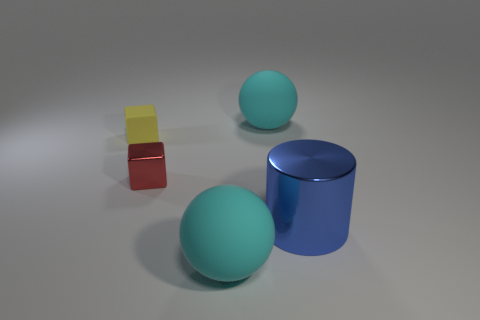Add 2 large cyan rubber spheres. How many objects exist? 7 Subtract all spheres. How many objects are left? 3 Add 3 large blue cylinders. How many large blue cylinders are left? 4 Add 5 red metal things. How many red metal things exist? 6 Subtract 0 gray balls. How many objects are left? 5 Subtract all tiny yellow objects. Subtract all big metal cylinders. How many objects are left? 3 